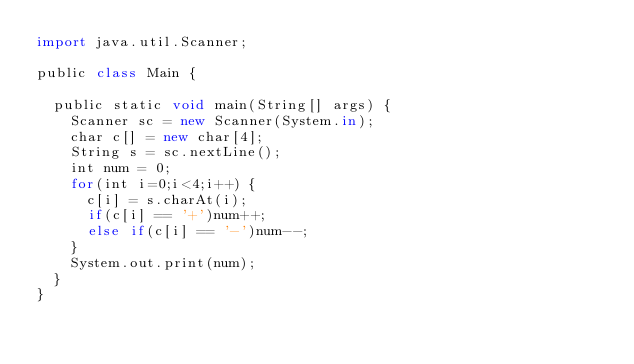<code> <loc_0><loc_0><loc_500><loc_500><_JavaScript_>import java.util.Scanner;

public class Main {

	public static void main(String[] args) {
		Scanner sc = new Scanner(System.in);
		char c[] = new char[4];
		String s = sc.nextLine();
		int num = 0;
		for(int i=0;i<4;i++) {
			c[i] = s.charAt(i);
			if(c[i] == '+')num++;
			else if(c[i] == '-')num--;
		}
		System.out.print(num);
	}
}</code> 